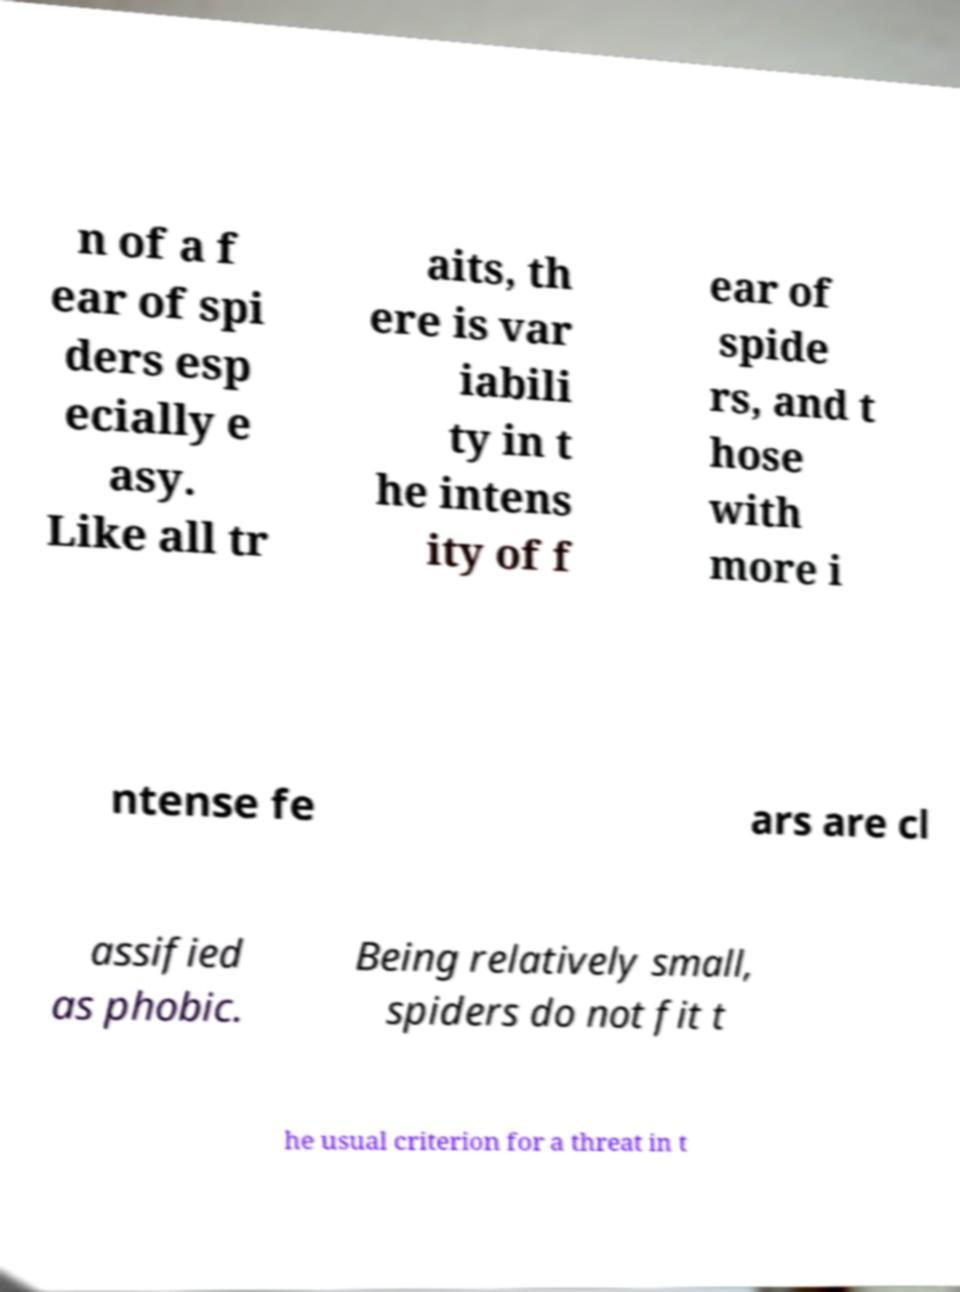I need the written content from this picture converted into text. Can you do that? n of a f ear of spi ders esp ecially e asy. Like all tr aits, th ere is var iabili ty in t he intens ity of f ear of spide rs, and t hose with more i ntense fe ars are cl assified as phobic. Being relatively small, spiders do not fit t he usual criterion for a threat in t 